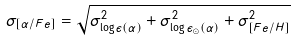<formula> <loc_0><loc_0><loc_500><loc_500>\sigma _ { [ \alpha / F e ] } = \sqrt { \sigma _ { \log \epsilon ( \alpha ) } ^ { 2 } + \sigma _ { \log \epsilon _ { \odot } ( \alpha ) } ^ { 2 } + \sigma _ { [ F e / H ] } ^ { 2 } }</formula> 